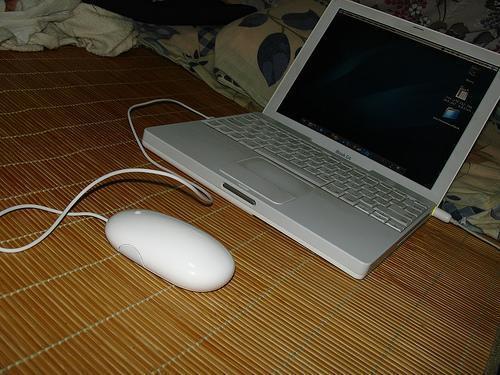How many laptops are visible?
Give a very brief answer. 1. How many shortcuts are visible on the laptop desktop?
Give a very brief answer. 3. 